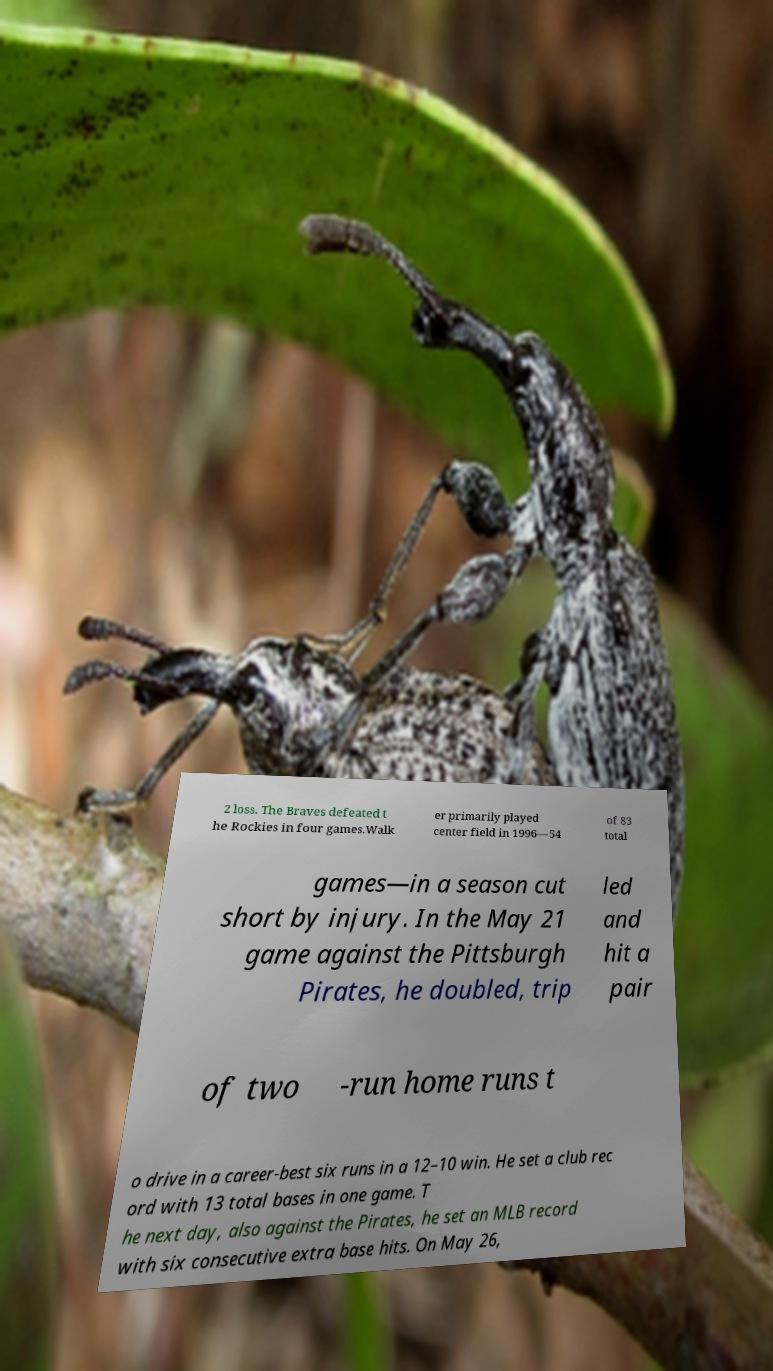Could you extract and type out the text from this image? 2 loss. The Braves defeated t he Rockies in four games.Walk er primarily played center field in 1996—54 of 83 total games—in a season cut short by injury. In the May 21 game against the Pittsburgh Pirates, he doubled, trip led and hit a pair of two -run home runs t o drive in a career-best six runs in a 12–10 win. He set a club rec ord with 13 total bases in one game. T he next day, also against the Pirates, he set an MLB record with six consecutive extra base hits. On May 26, 